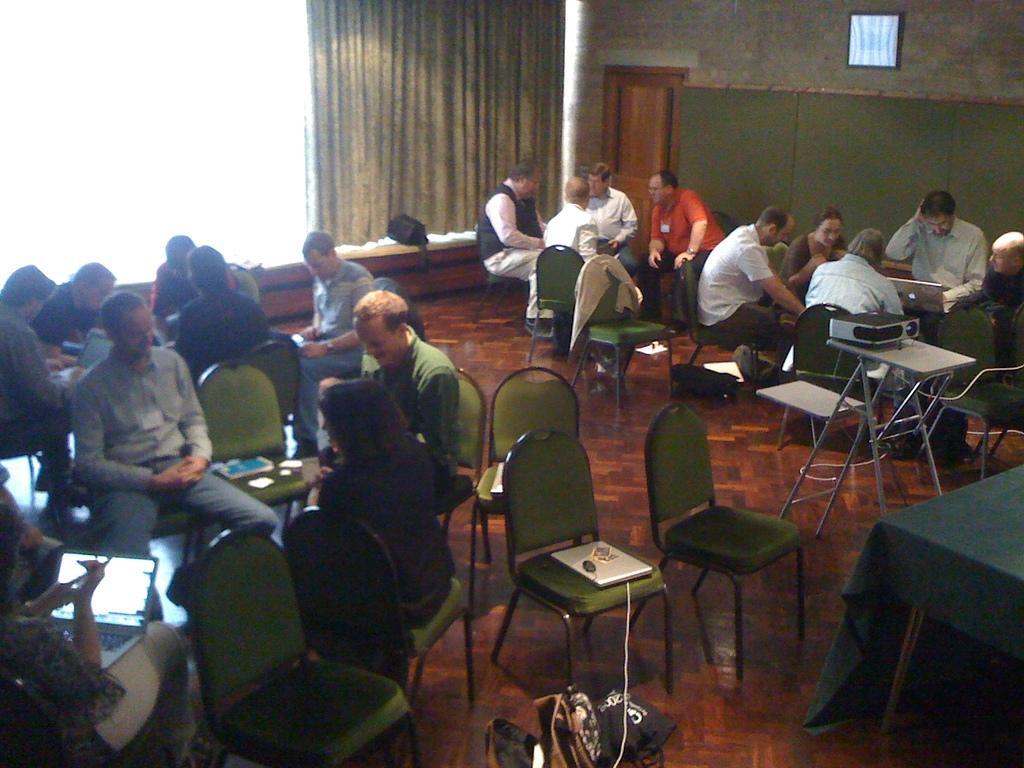Please provide a concise description of this image. Left a group of people sitting together on the chairs and talking to each other and at the left woman is sitting and looking into the laptop there is a wall and door in the right side of an image 